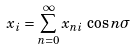Convert formula to latex. <formula><loc_0><loc_0><loc_500><loc_500>x _ { i } = \sum _ { n = 0 } ^ { \infty } x _ { n i } \, \cos n \sigma</formula> 